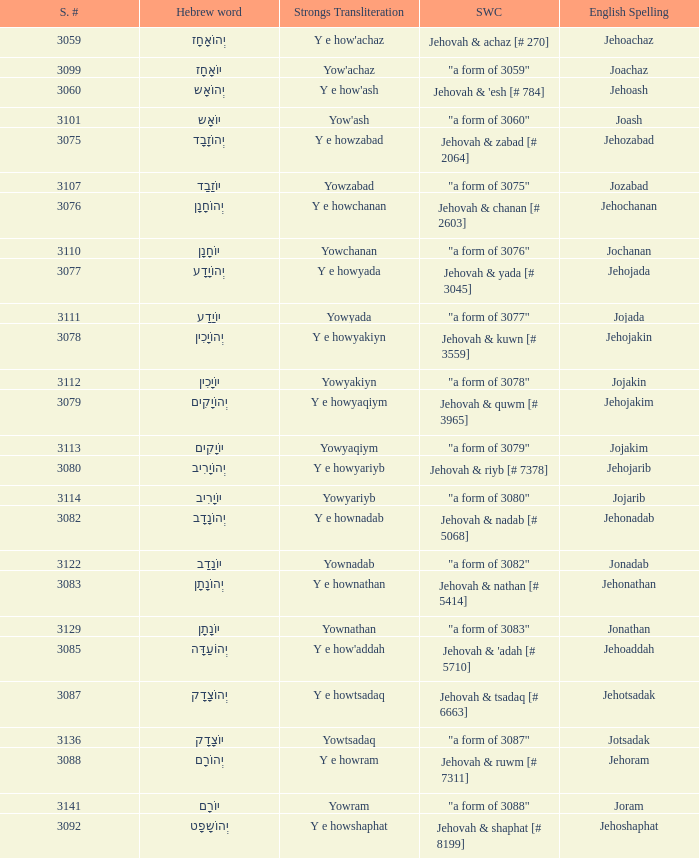How many strongs transliteration of the english spelling of the work jehojakin? 1.0. I'm looking to parse the entire table for insights. Could you assist me with that? {'header': ['S. #', 'Hebrew word', 'Strongs Transliteration', 'SWC', 'English Spelling'], 'rows': [['3059', 'יְהוֹאָחָז', "Y e how'achaz", 'Jehovah & achaz [# 270]', 'Jehoachaz'], ['3099', 'יוֹאָחָז', "Yow'achaz", '"a form of 3059"', 'Joachaz'], ['3060', 'יְהוֹאָש', "Y e how'ash", "Jehovah & 'esh [# 784]", 'Jehoash'], ['3101', 'יוֹאָש', "Yow'ash", '"a form of 3060"', 'Joash'], ['3075', 'יְהוֹזָבָד', 'Y e howzabad', 'Jehovah & zabad [# 2064]', 'Jehozabad'], ['3107', 'יוֹזָבָד', 'Yowzabad', '"a form of 3075"', 'Jozabad'], ['3076', 'יְהוֹחָנָן', 'Y e howchanan', 'Jehovah & chanan [# 2603]', 'Jehochanan'], ['3110', 'יוֹחָנָן', 'Yowchanan', '"a form of 3076"', 'Jochanan'], ['3077', 'יְהוֹיָדָע', 'Y e howyada', 'Jehovah & yada [# 3045]', 'Jehojada'], ['3111', 'יוֹיָדָע', 'Yowyada', '"a form of 3077"', 'Jojada'], ['3078', 'יְהוֹיָכִין', 'Y e howyakiyn', 'Jehovah & kuwn [# 3559]', 'Jehojakin'], ['3112', 'יוֹיָכִין', 'Yowyakiyn', '"a form of 3078"', 'Jojakin'], ['3079', 'יְהוֹיָקִים', 'Y e howyaqiym', 'Jehovah & quwm [# 3965]', 'Jehojakim'], ['3113', 'יוֹיָקִים', 'Yowyaqiym', '"a form of 3079"', 'Jojakim'], ['3080', 'יְהוֹיָרִיב', 'Y e howyariyb', 'Jehovah & riyb [# 7378]', 'Jehojarib'], ['3114', 'יוֹיָרִיב', 'Yowyariyb', '"a form of 3080"', 'Jojarib'], ['3082', 'יְהוֹנָדָב', 'Y e hownadab', 'Jehovah & nadab [# 5068]', 'Jehonadab'], ['3122', 'יוֹנָדָב', 'Yownadab', '"a form of 3082"', 'Jonadab'], ['3083', 'יְהוֹנָתָן', 'Y e hownathan', 'Jehovah & nathan [# 5414]', 'Jehonathan'], ['3129', 'יוֹנָתָן', 'Yownathan', '"a form of 3083"', 'Jonathan'], ['3085', 'יְהוֹעַדָּה', "Y e how'addah", "Jehovah & 'adah [# 5710]", 'Jehoaddah'], ['3087', 'יְהוֹצָדָק', 'Y e howtsadaq', 'Jehovah & tsadaq [# 6663]', 'Jehotsadak'], ['3136', 'יוֹצָדָק', 'Yowtsadaq', '"a form of 3087"', 'Jotsadak'], ['3088', 'יְהוֹרָם', 'Y e howram', 'Jehovah & ruwm [# 7311]', 'Jehoram'], ['3141', 'יוֹרָם', 'Yowram', '"a form of 3088"', 'Joram'], ['3092', 'יְהוֹשָפָט', 'Y e howshaphat', 'Jehovah & shaphat [# 8199]', 'Jehoshaphat']]} 